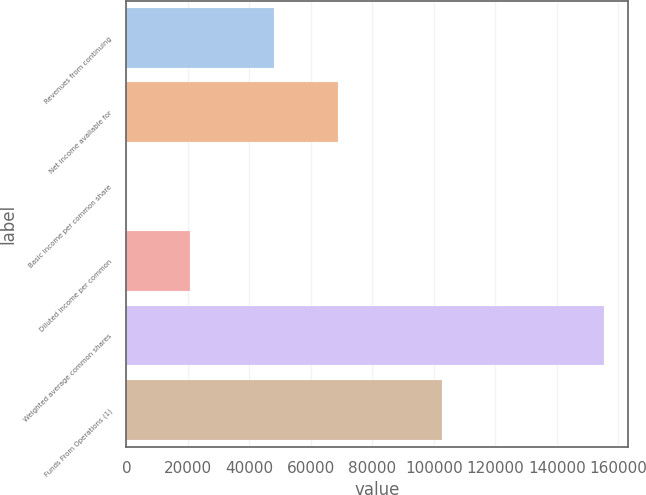<chart> <loc_0><loc_0><loc_500><loc_500><bar_chart><fcel>Revenues from continuing<fcel>Net income available for<fcel>Basic income per common share<fcel>Diluted income per common<fcel>Weighted average common shares<fcel>Funds From Operations (1)<nl><fcel>47927<fcel>68769.4<fcel>0.37<fcel>20842.7<fcel>155507<fcel>102788<nl></chart> 